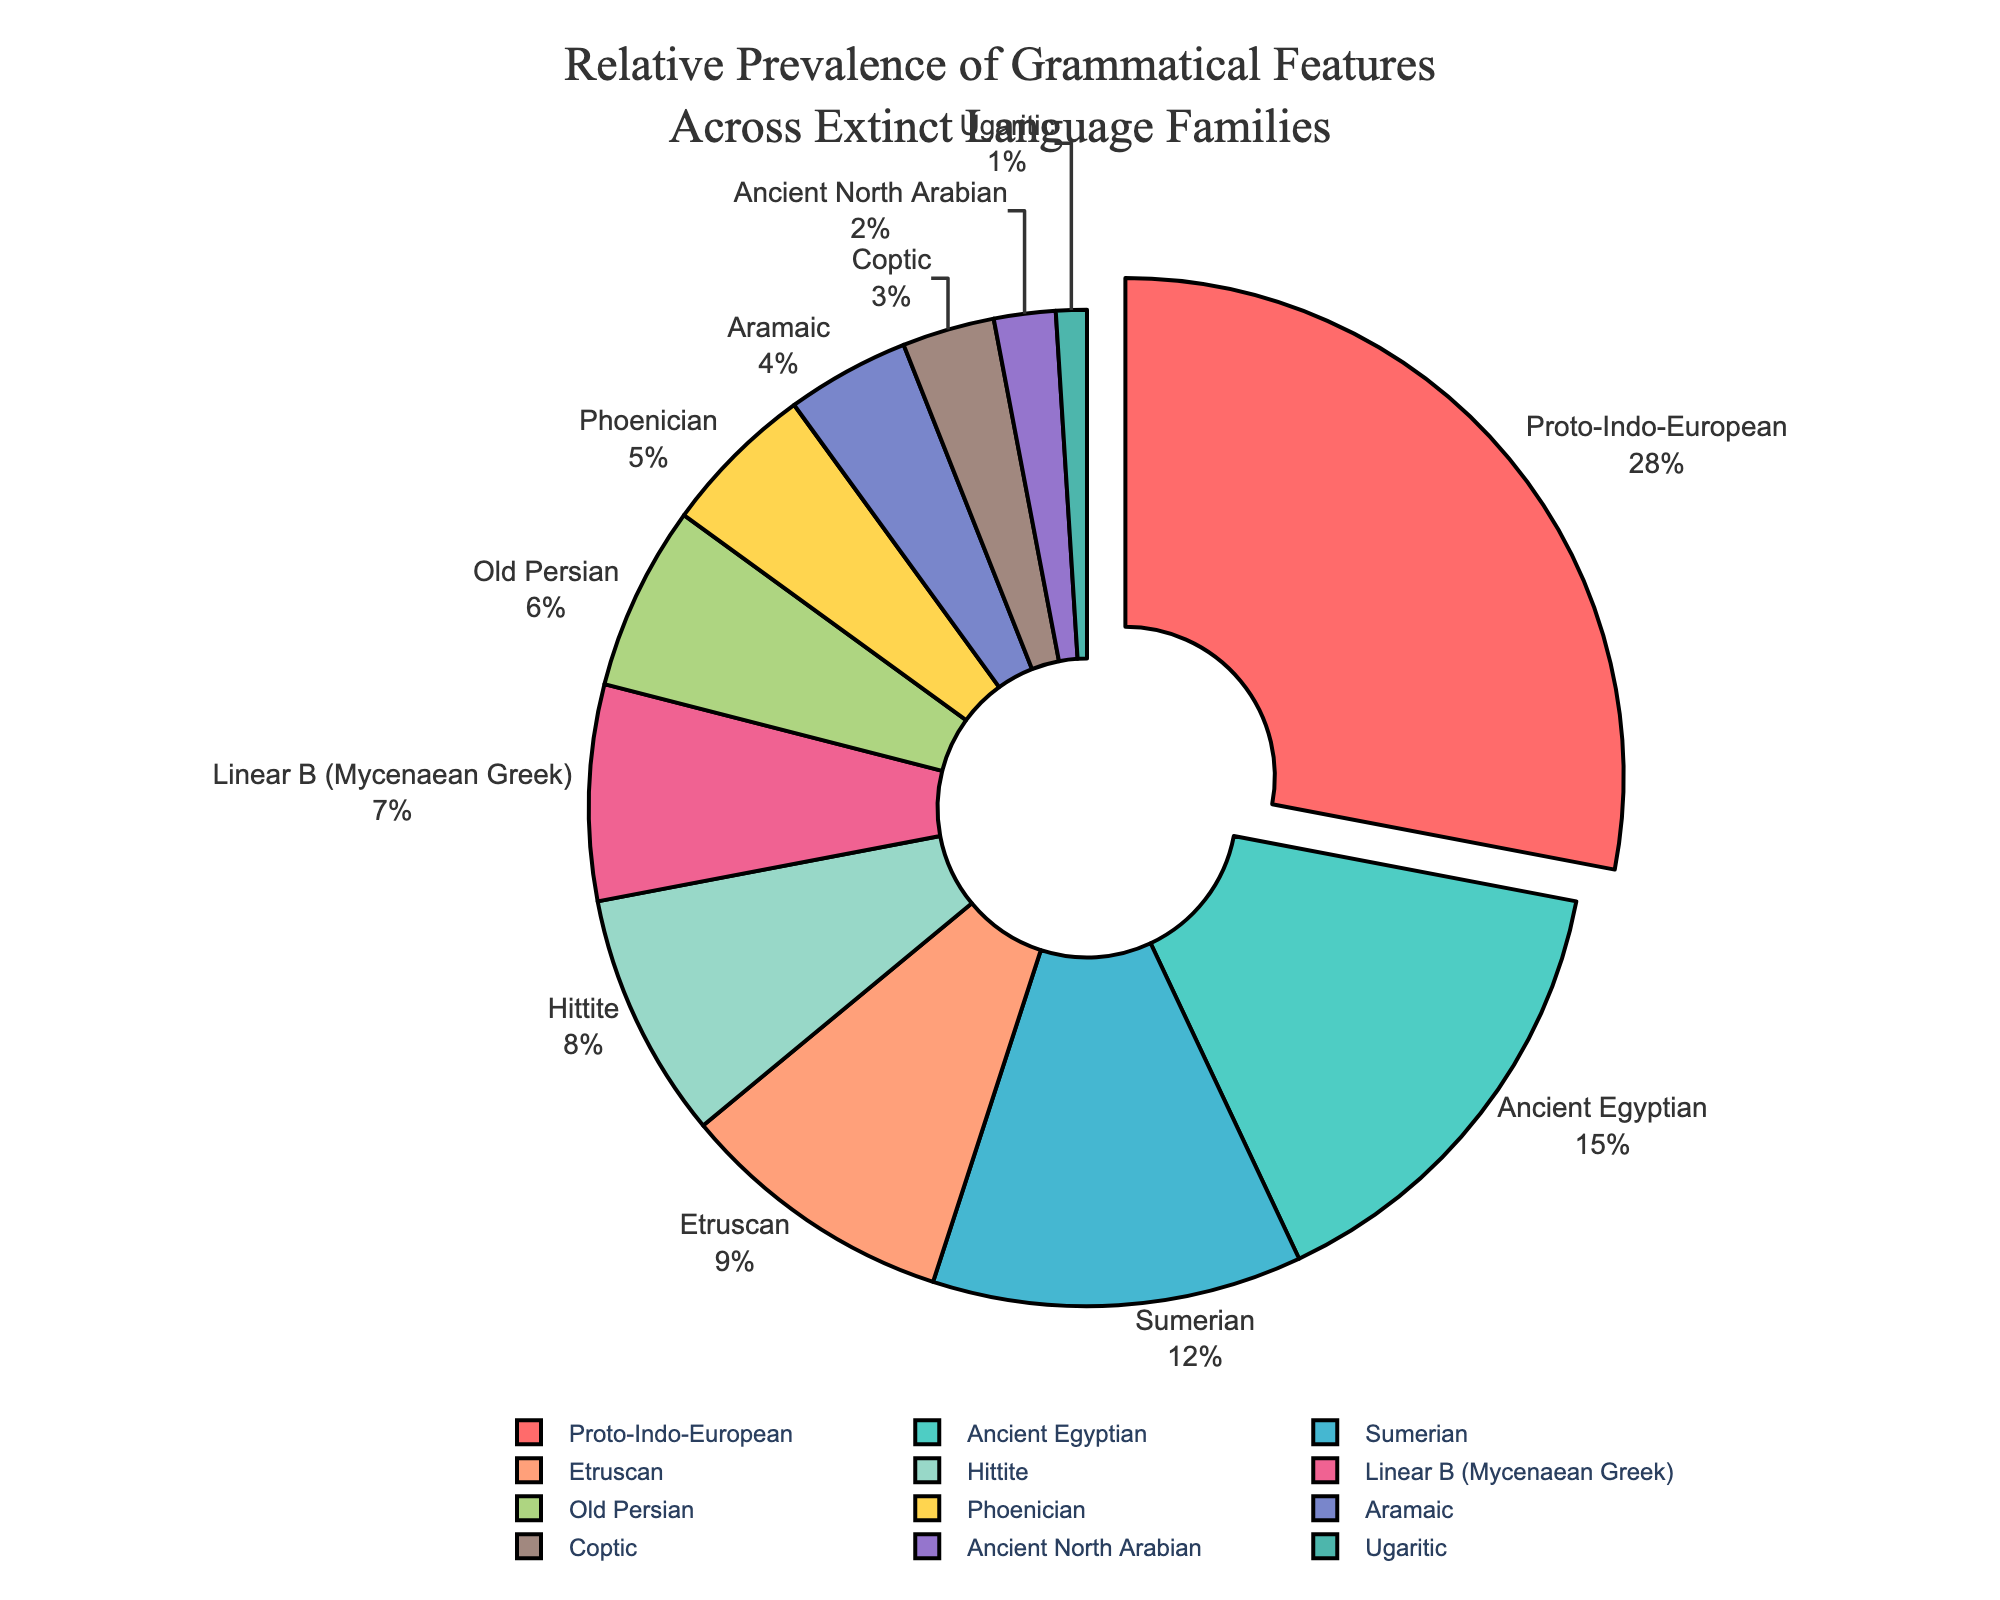Which language family has the largest prevalence of grammatical features? The largest section of the pie chart corresponds to the language family that has the largest prevalence. In this case, it is the Proto-Indo-European section.
Answer: Proto-Indo-European How much more prevalent are the grammatical features in Sumerian compared to Etruscan? To find out how much more prevalent the grammatical features are in Sumerian compared to Etruscan, look at the respective percentages and subtract the smaller percentage from the larger one: 12% - 9%.
Answer: 3% What is the combined prevalence of grammatical features in Ancient Egyptian, Hittite, and Aramaic? To find the combined prevalence, add the percentages of Ancient Egyptian (15%), Hittite (8%), and Aramaic (4%): 15% + 8% + 4%.
Answer: 27% Which language family has the least prevalence of grammatical features, and what is its percentage? The smallest section of the pie chart represents the language family with the least prevalence. In this case, it is Ugaritic, and its percentage is 1%.
Answer: Ugaritic, 1% Are the grammatical features of Ancient North Arabian more prevalent than those of Coptic? Compare the percentages of Ancient North Arabian (2%) and Coptic (3%). Ancient North Arabian has a smaller percentage than Coptic.
Answer: No Which color represents Phoenician and what is its percentage? Identify the segment labeled "Phoenician" on the pie chart and note its associated color and percentage. Phoenician is represented by a specific color and has a percentage of 5%.
Answer: (Identify the color visually), 5% How does the prevalence of Linear B grammatical features compare to Old Persian? Compare the percentages of Linear B (7%) and Old Persian (6%). Linear B has a slightly higher percentage than Old Persian.
Answer: Linear B is more prevalent What is the proportion of grammatical features represented by Proto-Indo-European compared to the total of Ancient Egyptian and Sumerian? First, sum the percentages of Ancient Egyptian (15%) and Sumerian (12%) to get 27%. Then divide the percentage of Proto-Indo-European (28%) by this sum: 28% / 27%.
Answer: Slightly more than 1 (or 28% to 27%) If you combine the prevalence of Hittite and Linear B, how does that compare to Proto-Indo-European? Sum the percentages of Hittite (8%) and Linear B (7%) to get 15%. Compare this to the percentage of Proto-Indo-European (28%).
Answer: 15% is less than 28% What percentage of the grammatical features is shared by the less prevalent languages (Ugaritic, Ancient North Arabian, and Coptic) combined? Sum the percentages of Ugaritic (1%), Ancient North Arabian (2%), and Coptic (3%): 1% + 2% + 3%.
Answer: 6% 